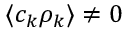Convert formula to latex. <formula><loc_0><loc_0><loc_500><loc_500>\langle c _ { k } \rho _ { k } \rangle \neq 0</formula> 